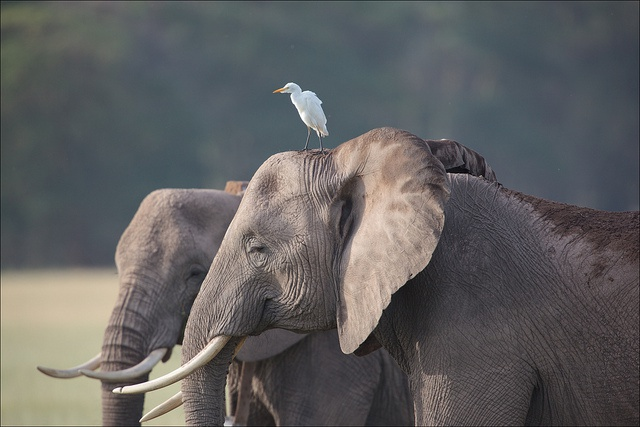Describe the objects in this image and their specific colors. I can see elephant in black, gray, darkgray, and tan tones, elephant in black, gray, and darkgray tones, and bird in black, darkgray, gray, and lightgray tones in this image. 